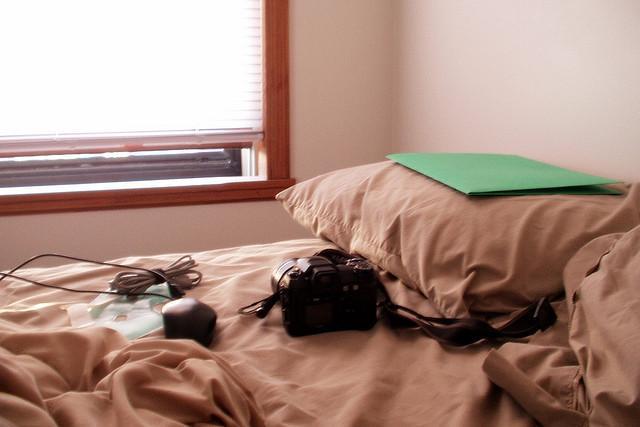How many beds are there?
Give a very brief answer. 1. How many of these people appear to be wearing glasses?
Give a very brief answer. 0. 